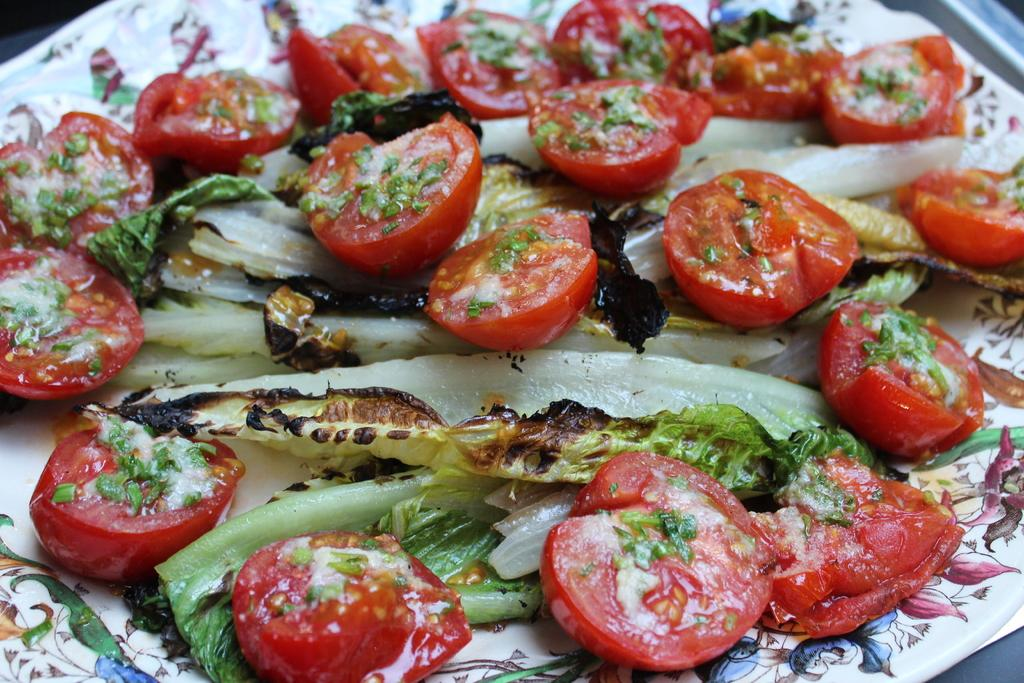What is on the plate that is visible in the image? The plate contains a salad in the image. What specific ingredients can be seen in the salad? The salad includes tomatoes and cabbage, as well as other vegetables. How many books are stacked on the plate in the image? There are no books present on the plate in the image; it contains a salad. 